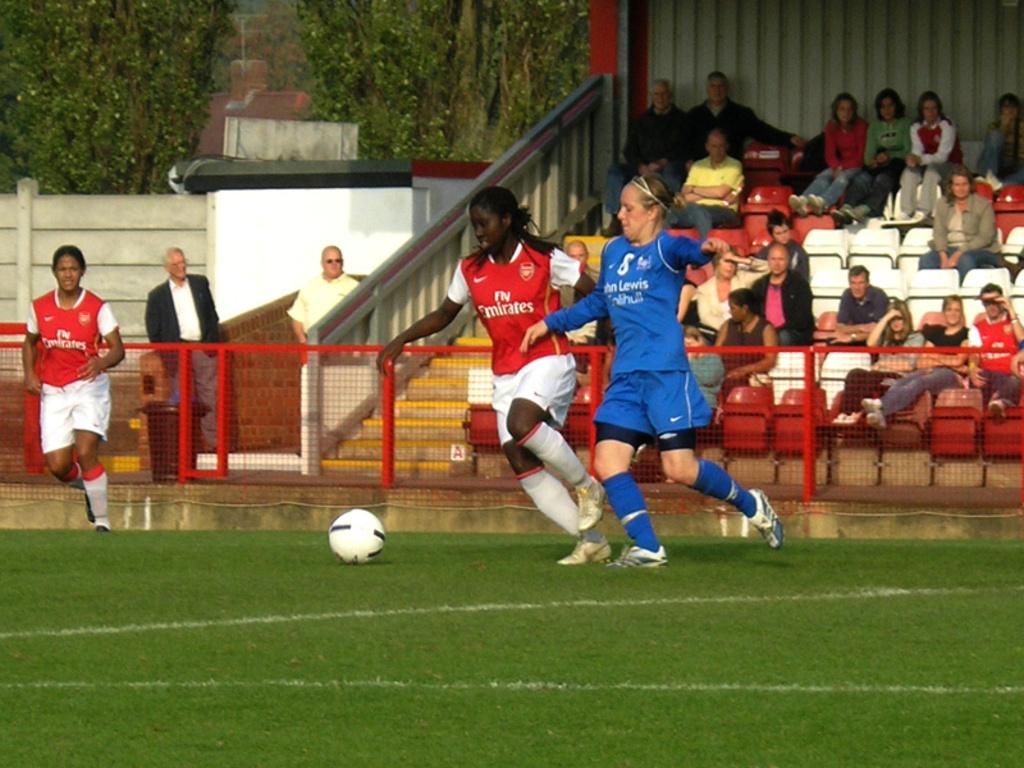What is the name mentioned on the blue jersey?
Give a very brief answer. Unanswerable. 